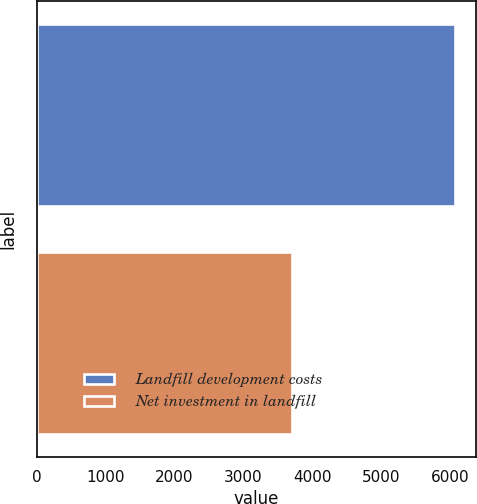<chart> <loc_0><loc_0><loc_500><loc_500><bar_chart><fcel>Landfill development costs<fcel>Net investment in landfill<nl><fcel>6078.1<fcel>3712.3<nl></chart> 